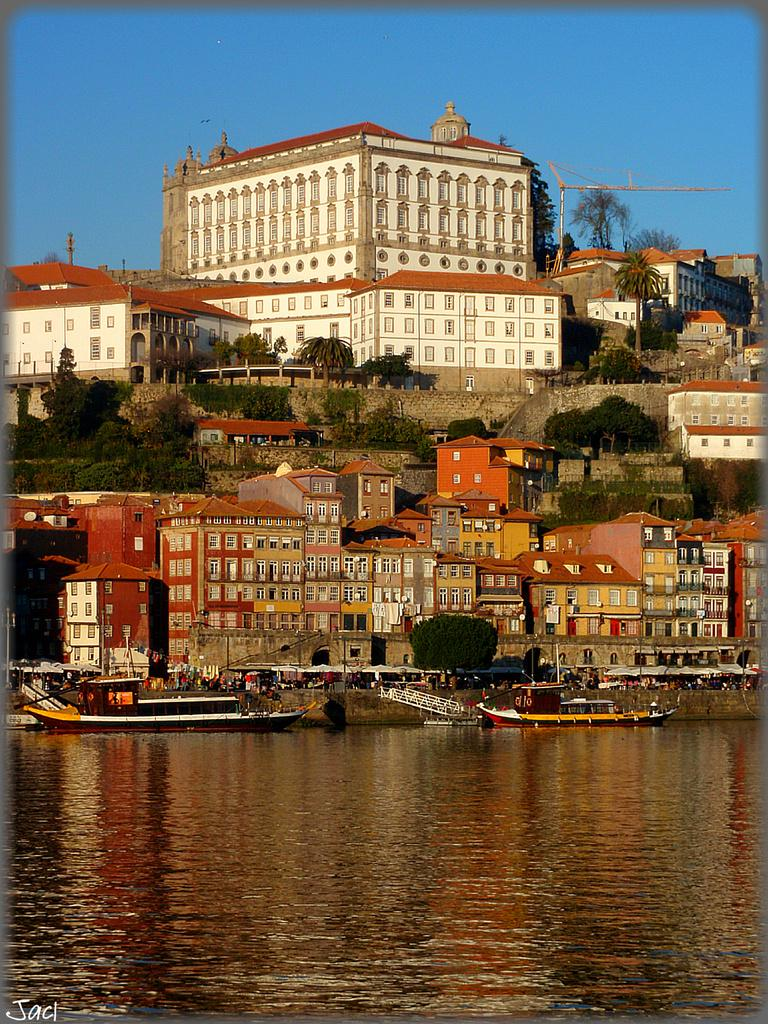What is on the water in the image? There are boats on the water in the image. What can be seen in the distance behind the boats? In the background, there are persons, buildings, trees, windows, walls, poles, and the sky visible. Can you describe the structures in the background? The background features buildings with windows and walls, as well as poles. What is the color of the sky in the image? The sky is visible in the background, but the color is not specified in the provided facts. Where is the basketball court located in the image? There is no basketball court present in the image. What type of needle can be seen sewing a piece of fabric in the image? There is no needle or fabric present in the image. 